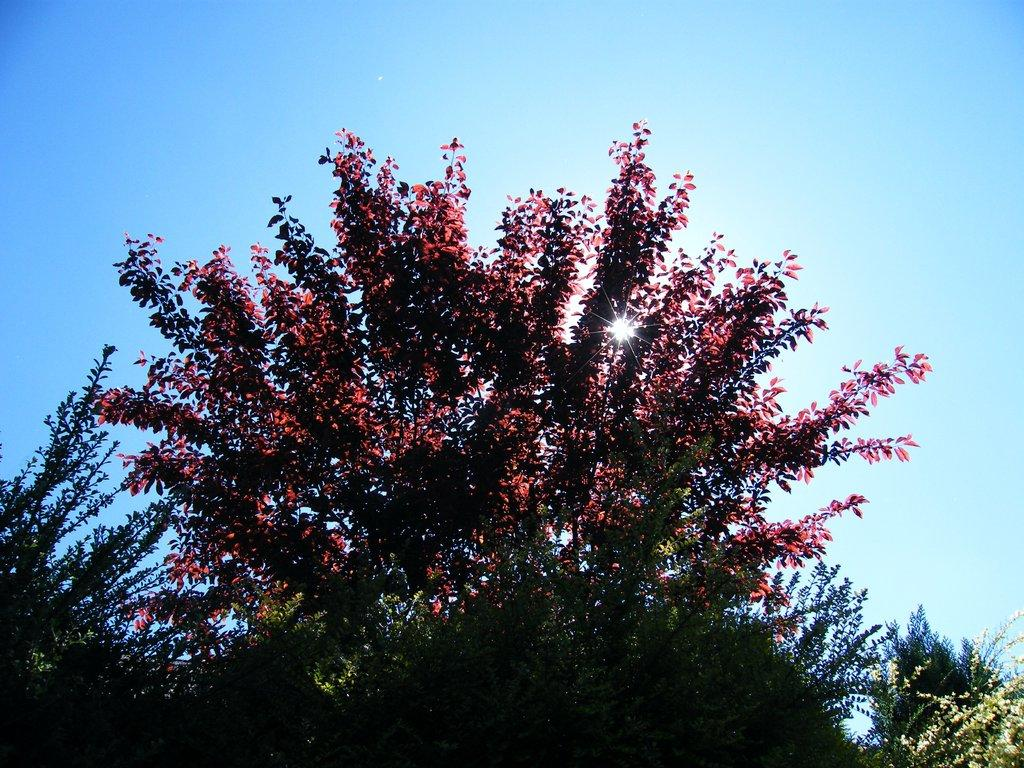What type of vegetation can be seen in the image? There are trees in the image. What part of the natural environment is visible in the image? The sky is visible in the background of the image. Are there any wooden toys hanging from the trees in the image? There is no mention of wooden toys in the image; it only features trees and the sky. Can you see any icicles hanging from the branches of the trees in the image? There is no mention of icicles in the image; it only features trees and the sky. 